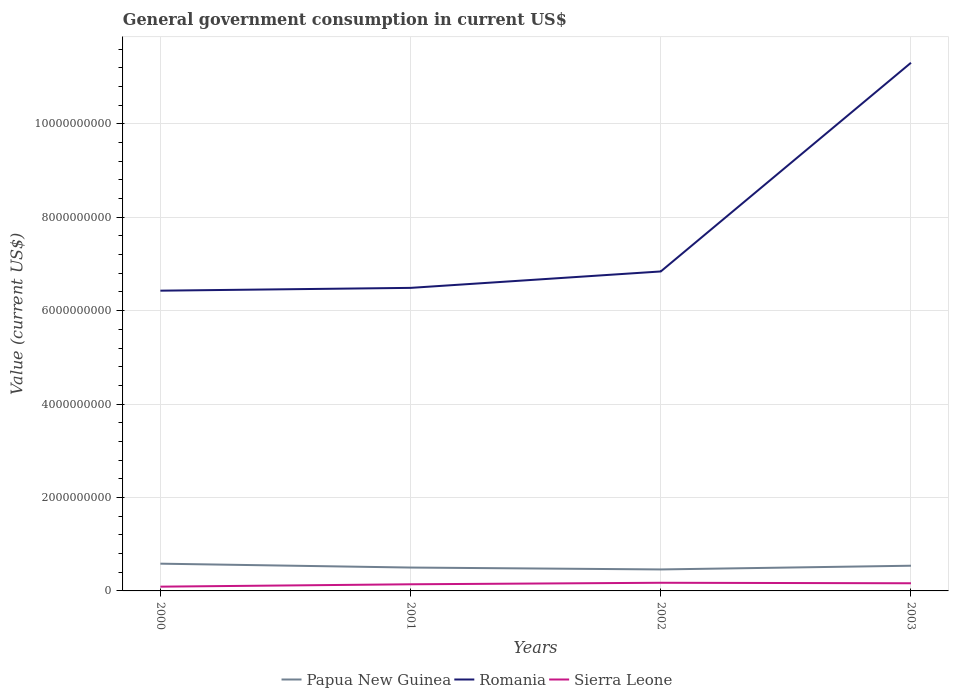Does the line corresponding to Papua New Guinea intersect with the line corresponding to Sierra Leone?
Ensure brevity in your answer.  No. Is the number of lines equal to the number of legend labels?
Provide a short and direct response. Yes. Across all years, what is the maximum government conusmption in Romania?
Your answer should be very brief. 6.43e+09. What is the total government conusmption in Papua New Guinea in the graph?
Keep it short and to the point. 8.32e+07. What is the difference between the highest and the second highest government conusmption in Papua New Guinea?
Make the answer very short. 1.23e+08. Is the government conusmption in Romania strictly greater than the government conusmption in Sierra Leone over the years?
Give a very brief answer. No. How many lines are there?
Provide a succinct answer. 3. How many years are there in the graph?
Your response must be concise. 4. What is the difference between two consecutive major ticks on the Y-axis?
Your response must be concise. 2.00e+09. Are the values on the major ticks of Y-axis written in scientific E-notation?
Give a very brief answer. No. Does the graph contain any zero values?
Offer a terse response. No. Does the graph contain grids?
Offer a very short reply. Yes. How many legend labels are there?
Your response must be concise. 3. How are the legend labels stacked?
Give a very brief answer. Horizontal. What is the title of the graph?
Give a very brief answer. General government consumption in current US$. Does "Latin America(developing only)" appear as one of the legend labels in the graph?
Offer a very short reply. No. What is the label or title of the Y-axis?
Your answer should be compact. Value (current US$). What is the Value (current US$) in Papua New Guinea in 2000?
Provide a short and direct response. 5.83e+08. What is the Value (current US$) in Romania in 2000?
Your response must be concise. 6.43e+09. What is the Value (current US$) of Sierra Leone in 2000?
Your answer should be compact. 9.11e+07. What is the Value (current US$) in Papua New Guinea in 2001?
Provide a short and direct response. 5.00e+08. What is the Value (current US$) in Romania in 2001?
Provide a short and direct response. 6.49e+09. What is the Value (current US$) in Sierra Leone in 2001?
Give a very brief answer. 1.42e+08. What is the Value (current US$) in Papua New Guinea in 2002?
Offer a very short reply. 4.60e+08. What is the Value (current US$) of Romania in 2002?
Provide a succinct answer. 6.84e+09. What is the Value (current US$) of Sierra Leone in 2002?
Your answer should be compact. 1.75e+08. What is the Value (current US$) of Papua New Guinea in 2003?
Your answer should be very brief. 5.40e+08. What is the Value (current US$) of Romania in 2003?
Provide a succinct answer. 1.13e+1. What is the Value (current US$) of Sierra Leone in 2003?
Provide a short and direct response. 1.64e+08. Across all years, what is the maximum Value (current US$) of Papua New Guinea?
Make the answer very short. 5.83e+08. Across all years, what is the maximum Value (current US$) of Romania?
Make the answer very short. 1.13e+1. Across all years, what is the maximum Value (current US$) in Sierra Leone?
Provide a short and direct response. 1.75e+08. Across all years, what is the minimum Value (current US$) in Papua New Guinea?
Keep it short and to the point. 4.60e+08. Across all years, what is the minimum Value (current US$) of Romania?
Offer a terse response. 6.43e+09. Across all years, what is the minimum Value (current US$) of Sierra Leone?
Ensure brevity in your answer.  9.11e+07. What is the total Value (current US$) in Papua New Guinea in the graph?
Ensure brevity in your answer.  2.08e+09. What is the total Value (current US$) in Romania in the graph?
Keep it short and to the point. 3.11e+1. What is the total Value (current US$) in Sierra Leone in the graph?
Your response must be concise. 5.72e+08. What is the difference between the Value (current US$) of Papua New Guinea in 2000 and that in 2001?
Offer a very short reply. 8.32e+07. What is the difference between the Value (current US$) in Romania in 2000 and that in 2001?
Give a very brief answer. -5.99e+07. What is the difference between the Value (current US$) in Sierra Leone in 2000 and that in 2001?
Provide a short and direct response. -5.08e+07. What is the difference between the Value (current US$) of Papua New Guinea in 2000 and that in 2002?
Offer a very short reply. 1.23e+08. What is the difference between the Value (current US$) in Romania in 2000 and that in 2002?
Your answer should be very brief. -4.11e+08. What is the difference between the Value (current US$) in Sierra Leone in 2000 and that in 2002?
Your response must be concise. -8.34e+07. What is the difference between the Value (current US$) of Papua New Guinea in 2000 and that in 2003?
Ensure brevity in your answer.  4.39e+07. What is the difference between the Value (current US$) of Romania in 2000 and that in 2003?
Your answer should be compact. -4.88e+09. What is the difference between the Value (current US$) in Sierra Leone in 2000 and that in 2003?
Give a very brief answer. -7.28e+07. What is the difference between the Value (current US$) of Papua New Guinea in 2001 and that in 2002?
Provide a short and direct response. 4.02e+07. What is the difference between the Value (current US$) in Romania in 2001 and that in 2002?
Offer a very short reply. -3.51e+08. What is the difference between the Value (current US$) in Sierra Leone in 2001 and that in 2002?
Your answer should be very brief. -3.25e+07. What is the difference between the Value (current US$) of Papua New Guinea in 2001 and that in 2003?
Offer a terse response. -3.93e+07. What is the difference between the Value (current US$) in Romania in 2001 and that in 2003?
Provide a succinct answer. -4.82e+09. What is the difference between the Value (current US$) in Sierra Leone in 2001 and that in 2003?
Offer a very short reply. -2.19e+07. What is the difference between the Value (current US$) in Papua New Guinea in 2002 and that in 2003?
Keep it short and to the point. -7.95e+07. What is the difference between the Value (current US$) of Romania in 2002 and that in 2003?
Give a very brief answer. -4.47e+09. What is the difference between the Value (current US$) in Sierra Leone in 2002 and that in 2003?
Provide a succinct answer. 1.06e+07. What is the difference between the Value (current US$) of Papua New Guinea in 2000 and the Value (current US$) of Romania in 2001?
Your response must be concise. -5.90e+09. What is the difference between the Value (current US$) of Papua New Guinea in 2000 and the Value (current US$) of Sierra Leone in 2001?
Provide a short and direct response. 4.41e+08. What is the difference between the Value (current US$) in Romania in 2000 and the Value (current US$) in Sierra Leone in 2001?
Ensure brevity in your answer.  6.29e+09. What is the difference between the Value (current US$) in Papua New Guinea in 2000 and the Value (current US$) in Romania in 2002?
Ensure brevity in your answer.  -6.26e+09. What is the difference between the Value (current US$) of Papua New Guinea in 2000 and the Value (current US$) of Sierra Leone in 2002?
Offer a terse response. 4.09e+08. What is the difference between the Value (current US$) of Romania in 2000 and the Value (current US$) of Sierra Leone in 2002?
Make the answer very short. 6.25e+09. What is the difference between the Value (current US$) of Papua New Guinea in 2000 and the Value (current US$) of Romania in 2003?
Offer a terse response. -1.07e+1. What is the difference between the Value (current US$) in Papua New Guinea in 2000 and the Value (current US$) in Sierra Leone in 2003?
Your response must be concise. 4.20e+08. What is the difference between the Value (current US$) in Romania in 2000 and the Value (current US$) in Sierra Leone in 2003?
Keep it short and to the point. 6.26e+09. What is the difference between the Value (current US$) in Papua New Guinea in 2001 and the Value (current US$) in Romania in 2002?
Keep it short and to the point. -6.34e+09. What is the difference between the Value (current US$) of Papua New Guinea in 2001 and the Value (current US$) of Sierra Leone in 2002?
Ensure brevity in your answer.  3.26e+08. What is the difference between the Value (current US$) in Romania in 2001 and the Value (current US$) in Sierra Leone in 2002?
Your answer should be compact. 6.31e+09. What is the difference between the Value (current US$) of Papua New Guinea in 2001 and the Value (current US$) of Romania in 2003?
Provide a short and direct response. -1.08e+1. What is the difference between the Value (current US$) of Papua New Guinea in 2001 and the Value (current US$) of Sierra Leone in 2003?
Keep it short and to the point. 3.36e+08. What is the difference between the Value (current US$) of Romania in 2001 and the Value (current US$) of Sierra Leone in 2003?
Provide a short and direct response. 6.32e+09. What is the difference between the Value (current US$) of Papua New Guinea in 2002 and the Value (current US$) of Romania in 2003?
Your response must be concise. -1.08e+1. What is the difference between the Value (current US$) in Papua New Guinea in 2002 and the Value (current US$) in Sierra Leone in 2003?
Your response must be concise. 2.96e+08. What is the difference between the Value (current US$) of Romania in 2002 and the Value (current US$) of Sierra Leone in 2003?
Give a very brief answer. 6.67e+09. What is the average Value (current US$) in Papua New Guinea per year?
Give a very brief answer. 5.21e+08. What is the average Value (current US$) of Romania per year?
Provide a short and direct response. 7.76e+09. What is the average Value (current US$) of Sierra Leone per year?
Your answer should be compact. 1.43e+08. In the year 2000, what is the difference between the Value (current US$) in Papua New Guinea and Value (current US$) in Romania?
Give a very brief answer. -5.84e+09. In the year 2000, what is the difference between the Value (current US$) in Papua New Guinea and Value (current US$) in Sierra Leone?
Offer a very short reply. 4.92e+08. In the year 2000, what is the difference between the Value (current US$) of Romania and Value (current US$) of Sierra Leone?
Make the answer very short. 6.34e+09. In the year 2001, what is the difference between the Value (current US$) of Papua New Guinea and Value (current US$) of Romania?
Your answer should be very brief. -5.99e+09. In the year 2001, what is the difference between the Value (current US$) of Papua New Guinea and Value (current US$) of Sierra Leone?
Offer a very short reply. 3.58e+08. In the year 2001, what is the difference between the Value (current US$) of Romania and Value (current US$) of Sierra Leone?
Give a very brief answer. 6.35e+09. In the year 2002, what is the difference between the Value (current US$) of Papua New Guinea and Value (current US$) of Romania?
Offer a terse response. -6.38e+09. In the year 2002, what is the difference between the Value (current US$) of Papua New Guinea and Value (current US$) of Sierra Leone?
Offer a very short reply. 2.86e+08. In the year 2002, what is the difference between the Value (current US$) in Romania and Value (current US$) in Sierra Leone?
Provide a succinct answer. 6.66e+09. In the year 2003, what is the difference between the Value (current US$) in Papua New Guinea and Value (current US$) in Romania?
Your response must be concise. -1.08e+1. In the year 2003, what is the difference between the Value (current US$) in Papua New Guinea and Value (current US$) in Sierra Leone?
Give a very brief answer. 3.76e+08. In the year 2003, what is the difference between the Value (current US$) of Romania and Value (current US$) of Sierra Leone?
Keep it short and to the point. 1.11e+1. What is the ratio of the Value (current US$) of Papua New Guinea in 2000 to that in 2001?
Your answer should be compact. 1.17. What is the ratio of the Value (current US$) in Romania in 2000 to that in 2001?
Keep it short and to the point. 0.99. What is the ratio of the Value (current US$) of Sierra Leone in 2000 to that in 2001?
Provide a succinct answer. 0.64. What is the ratio of the Value (current US$) in Papua New Guinea in 2000 to that in 2002?
Make the answer very short. 1.27. What is the ratio of the Value (current US$) of Romania in 2000 to that in 2002?
Your response must be concise. 0.94. What is the ratio of the Value (current US$) of Sierra Leone in 2000 to that in 2002?
Keep it short and to the point. 0.52. What is the ratio of the Value (current US$) of Papua New Guinea in 2000 to that in 2003?
Your response must be concise. 1.08. What is the ratio of the Value (current US$) in Romania in 2000 to that in 2003?
Your answer should be very brief. 0.57. What is the ratio of the Value (current US$) of Sierra Leone in 2000 to that in 2003?
Give a very brief answer. 0.56. What is the ratio of the Value (current US$) of Papua New Guinea in 2001 to that in 2002?
Your answer should be compact. 1.09. What is the ratio of the Value (current US$) of Romania in 2001 to that in 2002?
Offer a terse response. 0.95. What is the ratio of the Value (current US$) of Sierra Leone in 2001 to that in 2002?
Your answer should be very brief. 0.81. What is the ratio of the Value (current US$) in Papua New Guinea in 2001 to that in 2003?
Your response must be concise. 0.93. What is the ratio of the Value (current US$) of Romania in 2001 to that in 2003?
Ensure brevity in your answer.  0.57. What is the ratio of the Value (current US$) in Sierra Leone in 2001 to that in 2003?
Your answer should be compact. 0.87. What is the ratio of the Value (current US$) of Papua New Guinea in 2002 to that in 2003?
Offer a very short reply. 0.85. What is the ratio of the Value (current US$) in Romania in 2002 to that in 2003?
Offer a very short reply. 0.6. What is the ratio of the Value (current US$) of Sierra Leone in 2002 to that in 2003?
Your response must be concise. 1.06. What is the difference between the highest and the second highest Value (current US$) of Papua New Guinea?
Make the answer very short. 4.39e+07. What is the difference between the highest and the second highest Value (current US$) in Romania?
Your response must be concise. 4.47e+09. What is the difference between the highest and the second highest Value (current US$) of Sierra Leone?
Give a very brief answer. 1.06e+07. What is the difference between the highest and the lowest Value (current US$) of Papua New Guinea?
Your answer should be very brief. 1.23e+08. What is the difference between the highest and the lowest Value (current US$) in Romania?
Ensure brevity in your answer.  4.88e+09. What is the difference between the highest and the lowest Value (current US$) in Sierra Leone?
Keep it short and to the point. 8.34e+07. 